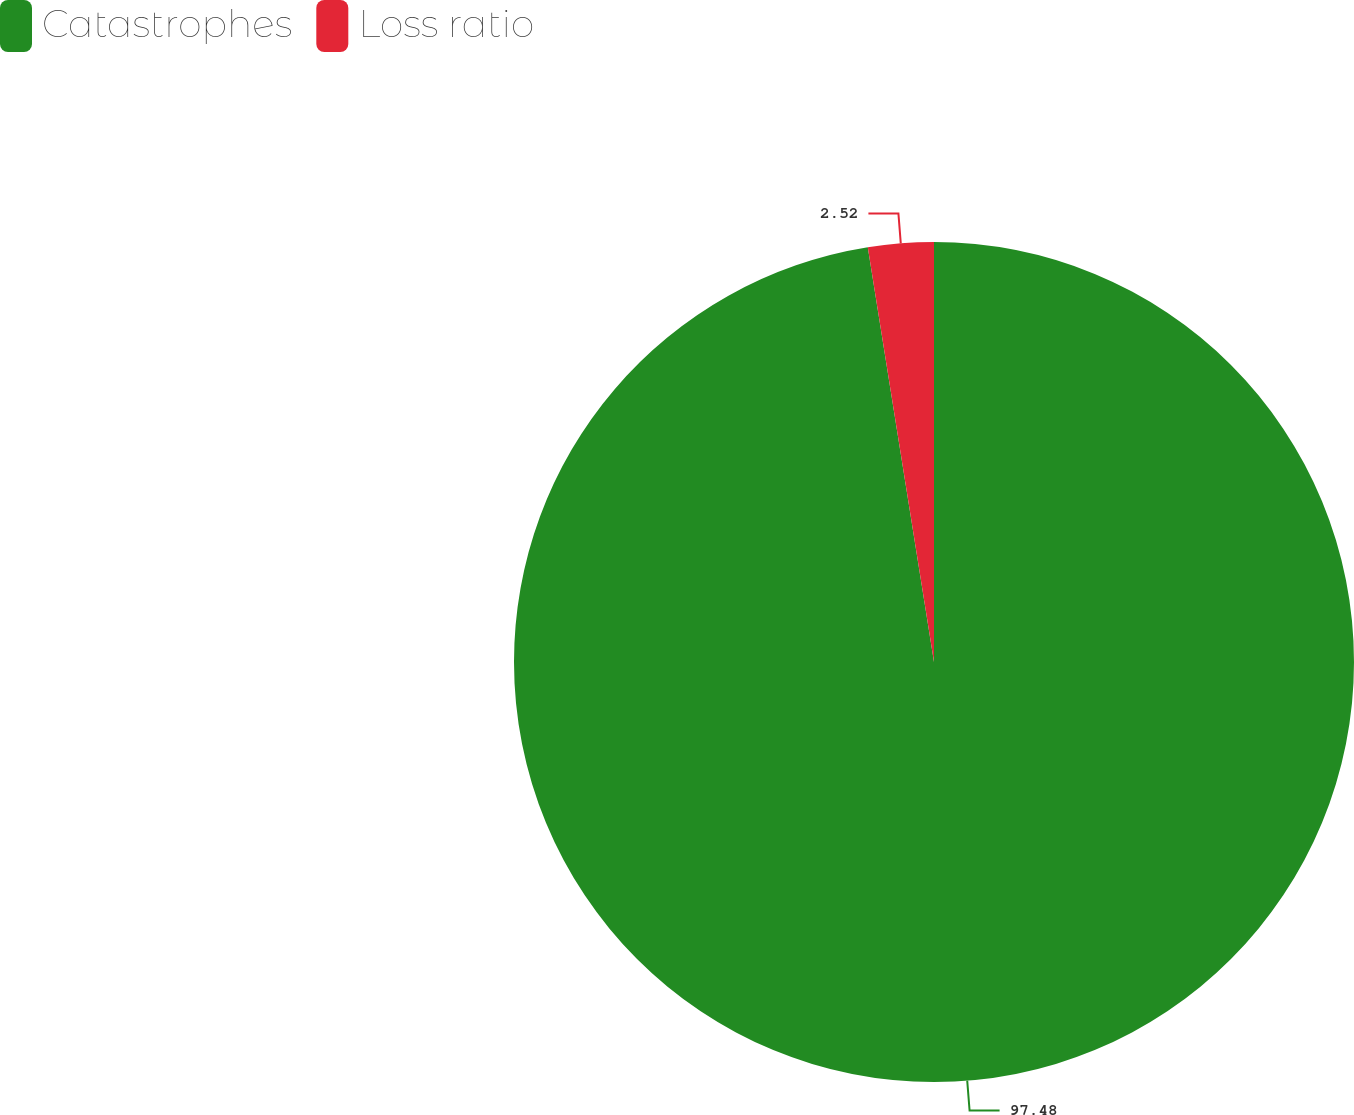<chart> <loc_0><loc_0><loc_500><loc_500><pie_chart><fcel>Catastrophes<fcel>Loss ratio<nl><fcel>97.48%<fcel>2.52%<nl></chart> 